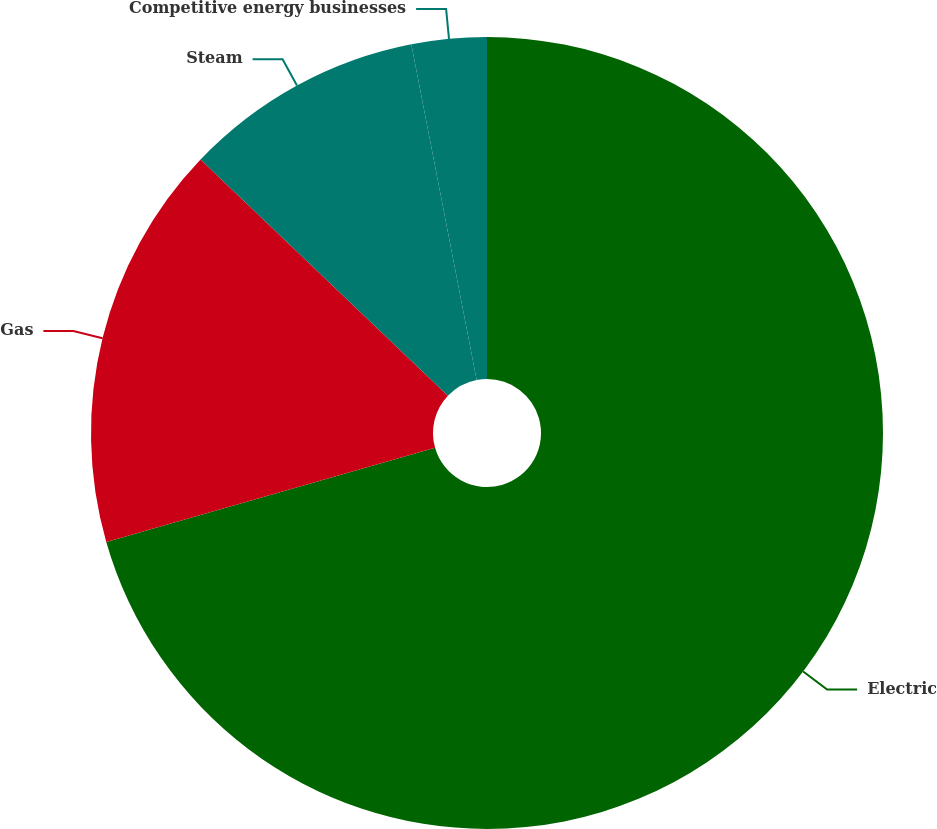<chart> <loc_0><loc_0><loc_500><loc_500><pie_chart><fcel>Electric<fcel>Gas<fcel>Steam<fcel>Competitive energy businesses<nl><fcel>70.56%<fcel>16.56%<fcel>9.81%<fcel>3.06%<nl></chart> 